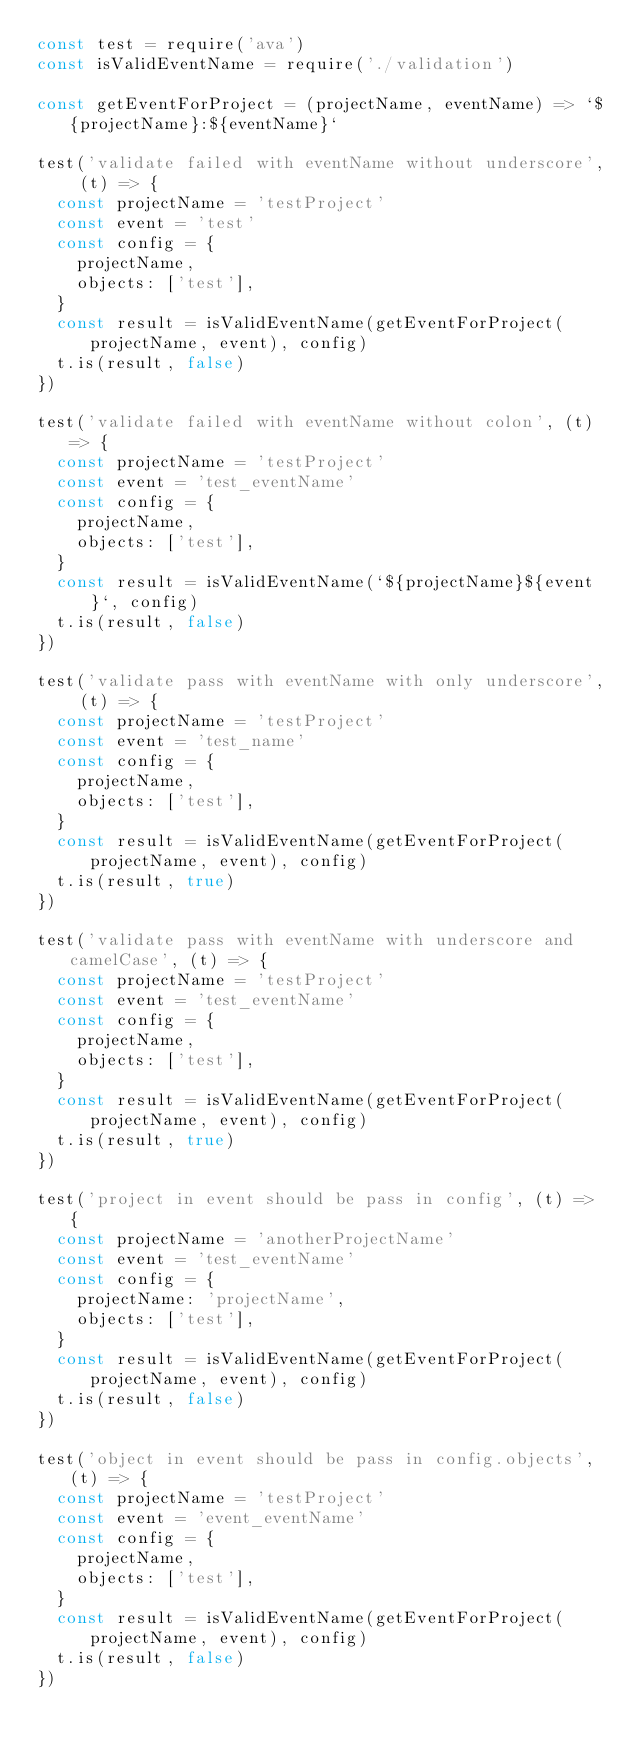<code> <loc_0><loc_0><loc_500><loc_500><_JavaScript_>const test = require('ava')
const isValidEventName = require('./validation')

const getEventForProject = (projectName, eventName) => `${projectName}:${eventName}`

test('validate failed with eventName without underscore', (t) => {
  const projectName = 'testProject'
  const event = 'test'
  const config = {
    projectName,
    objects: ['test'],
  }
  const result = isValidEventName(getEventForProject(projectName, event), config)
  t.is(result, false)
})

test('validate failed with eventName without colon', (t) => {
  const projectName = 'testProject'
  const event = 'test_eventName'
  const config = {
    projectName,
    objects: ['test'],
  }
  const result = isValidEventName(`${projectName}${event}`, config)
  t.is(result, false)
})

test('validate pass with eventName with only underscore', (t) => {
  const projectName = 'testProject'
  const event = 'test_name'
  const config = {
    projectName,
    objects: ['test'],
  }
  const result = isValidEventName(getEventForProject(projectName, event), config)
  t.is(result, true)
})

test('validate pass with eventName with underscore and camelCase', (t) => {
  const projectName = 'testProject'
  const event = 'test_eventName'
  const config = {
    projectName,
    objects: ['test'],
  }
  const result = isValidEventName(getEventForProject(projectName, event), config)
  t.is(result, true)
})

test('project in event should be pass in config', (t) => {
  const projectName = 'anotherProjectName'
  const event = 'test_eventName'
  const config = {
    projectName: 'projectName',
    objects: ['test'],
  }
  const result = isValidEventName(getEventForProject(projectName, event), config)
  t.is(result, false)
})

test('object in event should be pass in config.objects', (t) => {
  const projectName = 'testProject'
  const event = 'event_eventName'
  const config = {
    projectName,
    objects: ['test'],
  }
  const result = isValidEventName(getEventForProject(projectName, event), config)
  t.is(result, false)
})
</code> 